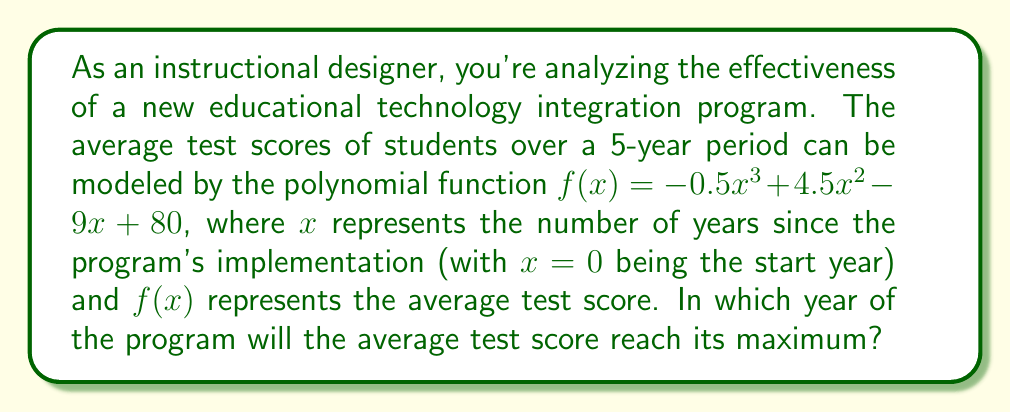Help me with this question. To find the year when the average test score reaches its maximum, we need to follow these steps:

1) First, we need to find the derivative of the function $f(x)$:
   $f'(x) = -1.5x^2 + 9x - 9$

2) The maximum point occurs where the derivative equals zero. So, we set $f'(x) = 0$:
   $-1.5x^2 + 9x - 9 = 0$

3) This is a quadratic equation. We can solve it using the quadratic formula:
   $x = \frac{-b \pm \sqrt{b^2 - 4ac}}{2a}$

   Where $a = -1.5$, $b = 9$, and $c = -9$

4) Substituting these values:
   $x = \frac{-9 \pm \sqrt{81 - 4(-1.5)(-9)}}{2(-1.5)}$
   $= \frac{-9 \pm \sqrt{81 - 54}}{-3}$
   $= \frac{-9 \pm \sqrt{27}}{-3}$
   $= \frac{-9 \pm 3\sqrt{3}}{-3}$

5) This gives us two solutions:
   $x_1 = \frac{-9 + 3\sqrt{3}}{-3} = 3 - \sqrt{3}$
   $x_2 = \frac{-9 - 3\sqrt{3}}{-3} = 3 + \sqrt{3}$

6) Since we're looking for a maximum point, and the coefficient of $x^3$ in the original function is negative, the smaller $x$ value will give us the maximum point.

7) Therefore, the maximum occurs at $x = 3 - \sqrt{3} \approx 1.27$ years.

8) Since we're dealing with whole years in this context, we round up to 2 years.
Answer: 2 years 